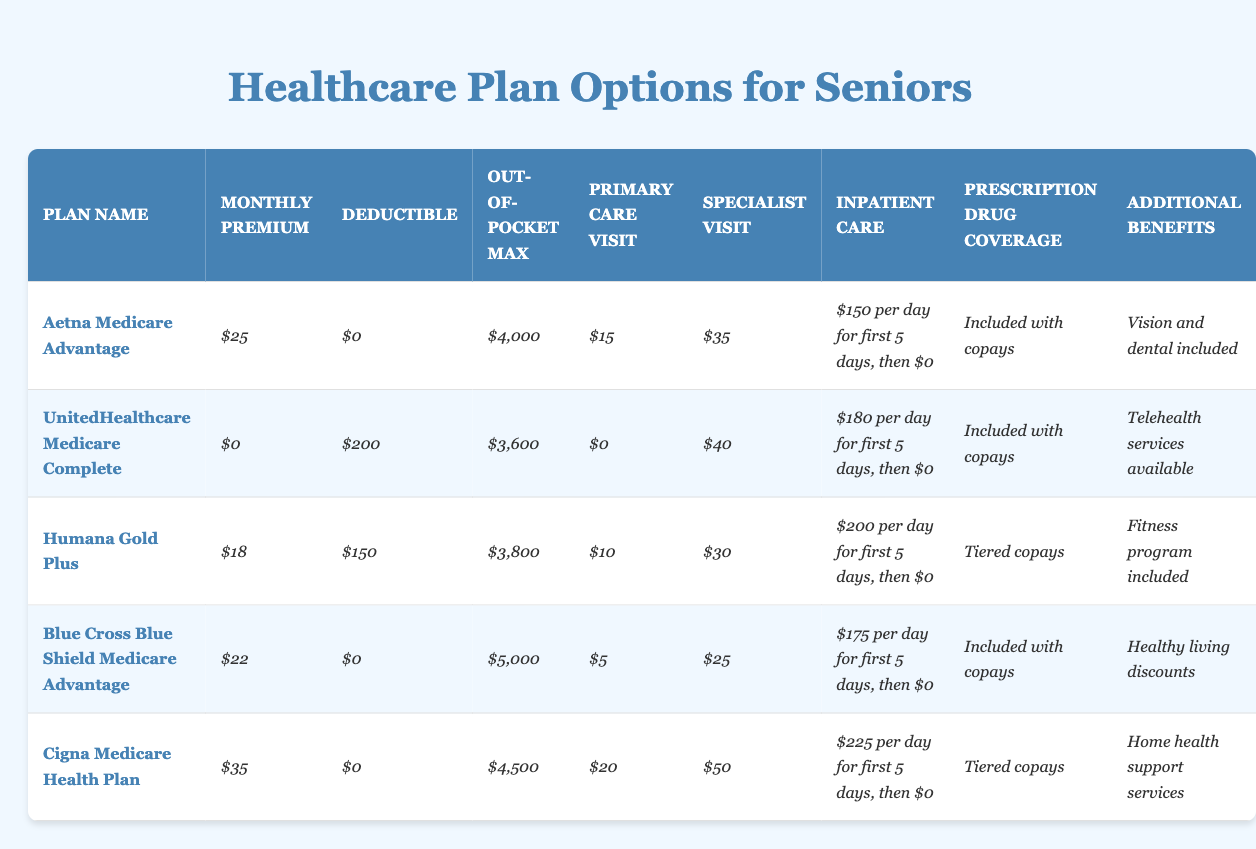What is the monthly premium for Aetna Medicare Advantage? The table lists the monthly premium for Aetna Medicare Advantage as $25.
Answer: $25 What is the out-of-pocket maximum for UnitedHealthcare Medicare Complete? The table shows that the out-of-pocket maximum for UnitedHealthcare Medicare Complete is $3,600.
Answer: $3,600 Which plan has the lowest deductible? In the table, UnitedHealthcare Medicare Complete has the lowest deductible of $200.
Answer: $200 What is the daily inpatient care cost for Humana Gold Plus for the first 5 days? The table indicates that Humana Gold Plus charges $200 per day for the first 5 days of inpatient care.
Answer: $200 Is there a monthly premium for the UnitedHealthcare Medicare Complete plan? According to the table, the monthly premium for UnitedHealthcare Medicare Complete is $0, indicating that there is no cost.
Answer: Yes Calculate the average monthly premium for all the plans listed. Adding the monthly premiums: 25 + 0 + 18 + 22 + 35 = 100. There are 5 plans, so the average is 100/5 = 20.
Answer: $20 Which plan has the most additional benefits? On comparing the additional benefits, Aetna Medicare Advantage and Cigna Medicare Health Plan only have one specific listed benefit, while UnitedHealthcare Medicare Complete offers telehealth services which could be more beneficial overall. Hence it's a more comprehensive benefit.
Answer: UnitedHealthcare Medicare Complete What is the difference between the out-of-pocket maximum for Cigna Medicare Health Plan and Blue Cross Blue Shield Medicare Advantage? The out-of-pocket maximum for Cigna Medicare Health Plan is $4,500 and for Blue Cross Blue Shield Medicare Advantage is $5,000. The difference is $5,000 - $4,500 = $500.
Answer: $500 For which plan is the primary care visit fee the lowest? The table shows that the primary care visit fee is lowest for UnitedHealthcare Medicare Complete at $0.
Answer: UnitedHealthcare Medicare Complete How much would inpatient care cost for the first 5 days under the Cigna Medicare Health Plan? The inpatient care cost for Cigna Medicare Health Plan is $225 per day for the first 5 days. Calculating total cost: 225 * 5 = $1,125.
Answer: $1,125 